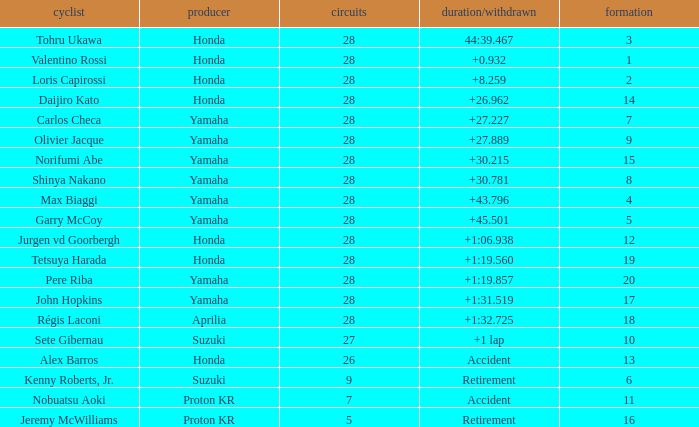Who manufactured grid 11? Proton KR. 